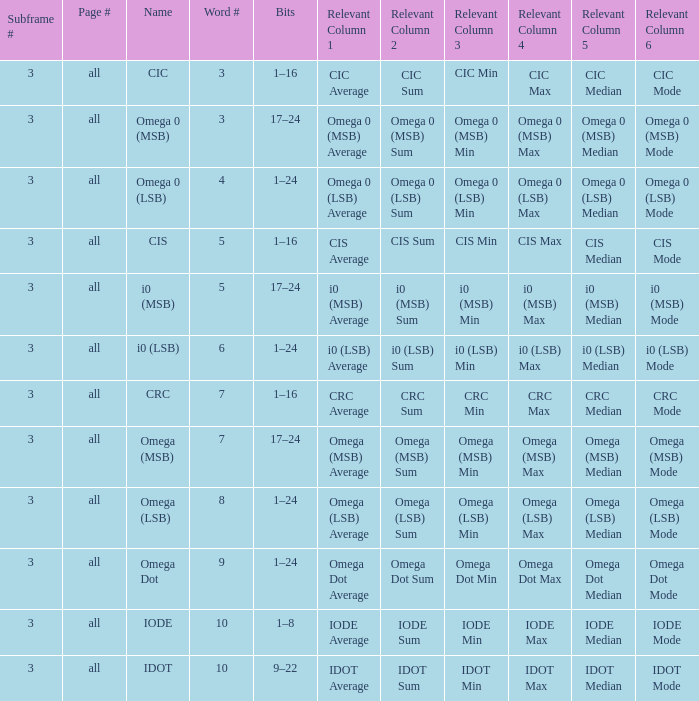What does the term omega dot represent in terms of word count? 9.0. 